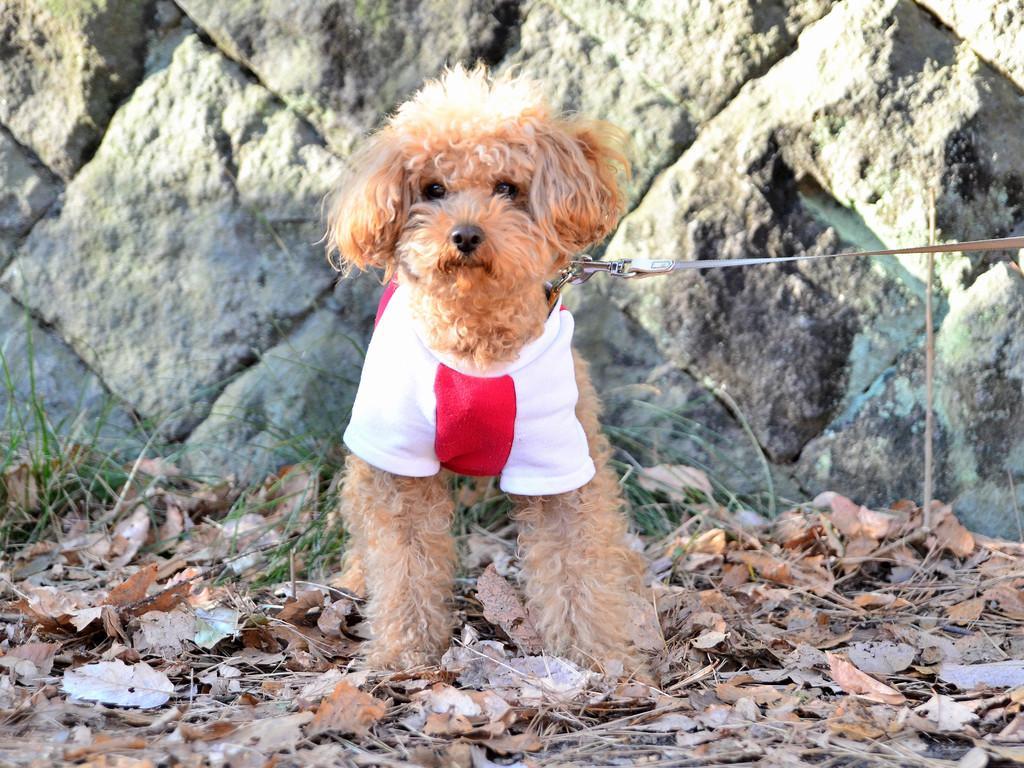Describe this image in one or two sentences. In this picture there is a dog which is in brown color is wearing a white and red color cloth and there is a belt attached to it and there is a wall behind it. 